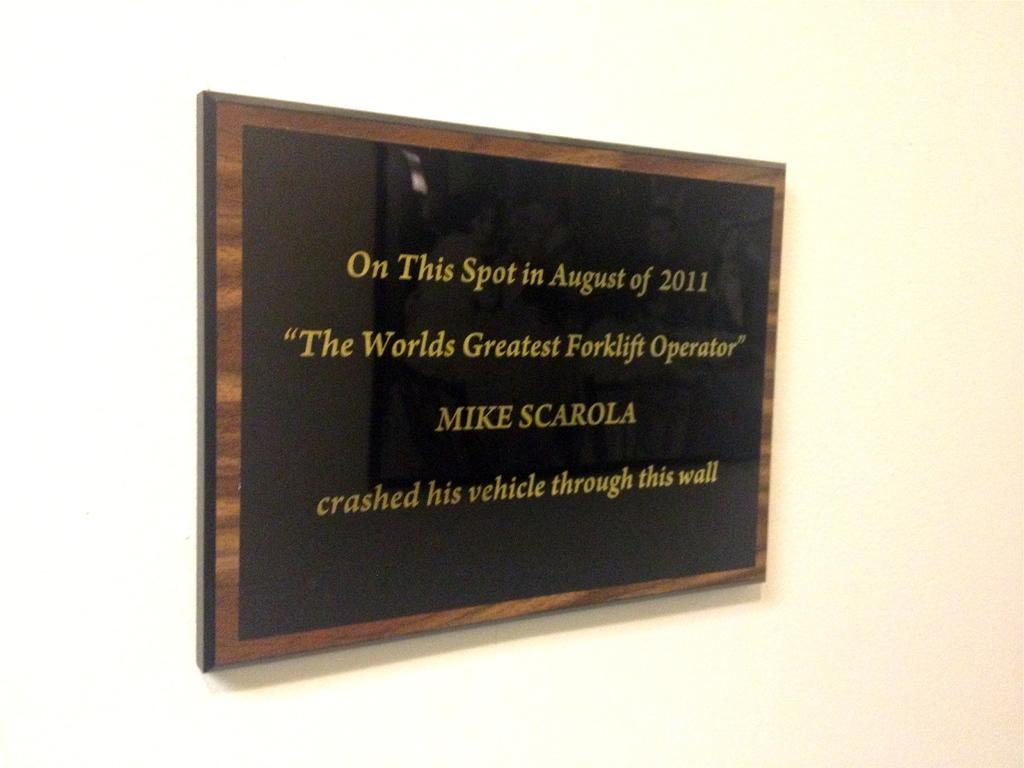<image>
Provide a brief description of the given image. a plaque with the words "on this spot in august of 201 mike scarola crashed his vehicle through this wall" 